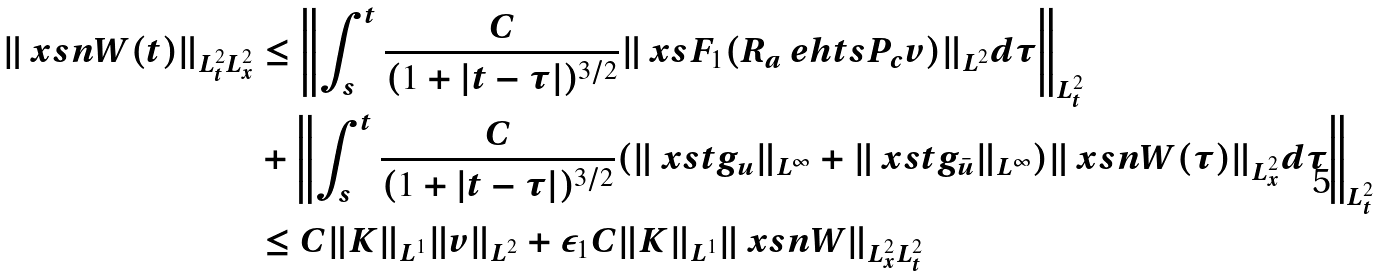<formula> <loc_0><loc_0><loc_500><loc_500>\| \ x s n W ( t ) \| _ { L _ { t } ^ { 2 } L _ { x } ^ { 2 } } & \leq \left \| \int _ { s } ^ { t } \frac { C } { ( 1 + | t - \tau | ) ^ { 3 / 2 } } \| \ x s F _ { 1 } ( R _ { a } \ e h t s P _ { c } v ) \| _ { L ^ { 2 } } d \tau \right \| _ { L ^ { 2 } _ { t } } \\ & + \left \| \int _ { s } ^ { t } \frac { C } { ( 1 + | t - \tau | ) ^ { 3 / 2 } } ( \| \ x s t g _ { u } \| _ { L ^ { \infty } } + \| \ x s t g _ { \bar { u } } \| _ { L ^ { \infty } } ) \| \ x s n W ( \tau ) \| _ { L ^ { 2 } _ { x } } d \tau \right \| _ { L ^ { 2 } _ { t } } \\ & \leq C \| K \| _ { L ^ { 1 } } \| v \| _ { L ^ { 2 } } + \varepsilon _ { 1 } C \| K \| _ { L ^ { 1 } } \| \ x s n W \| _ { L ^ { 2 } _ { x } L ^ { 2 } _ { t } }</formula> 